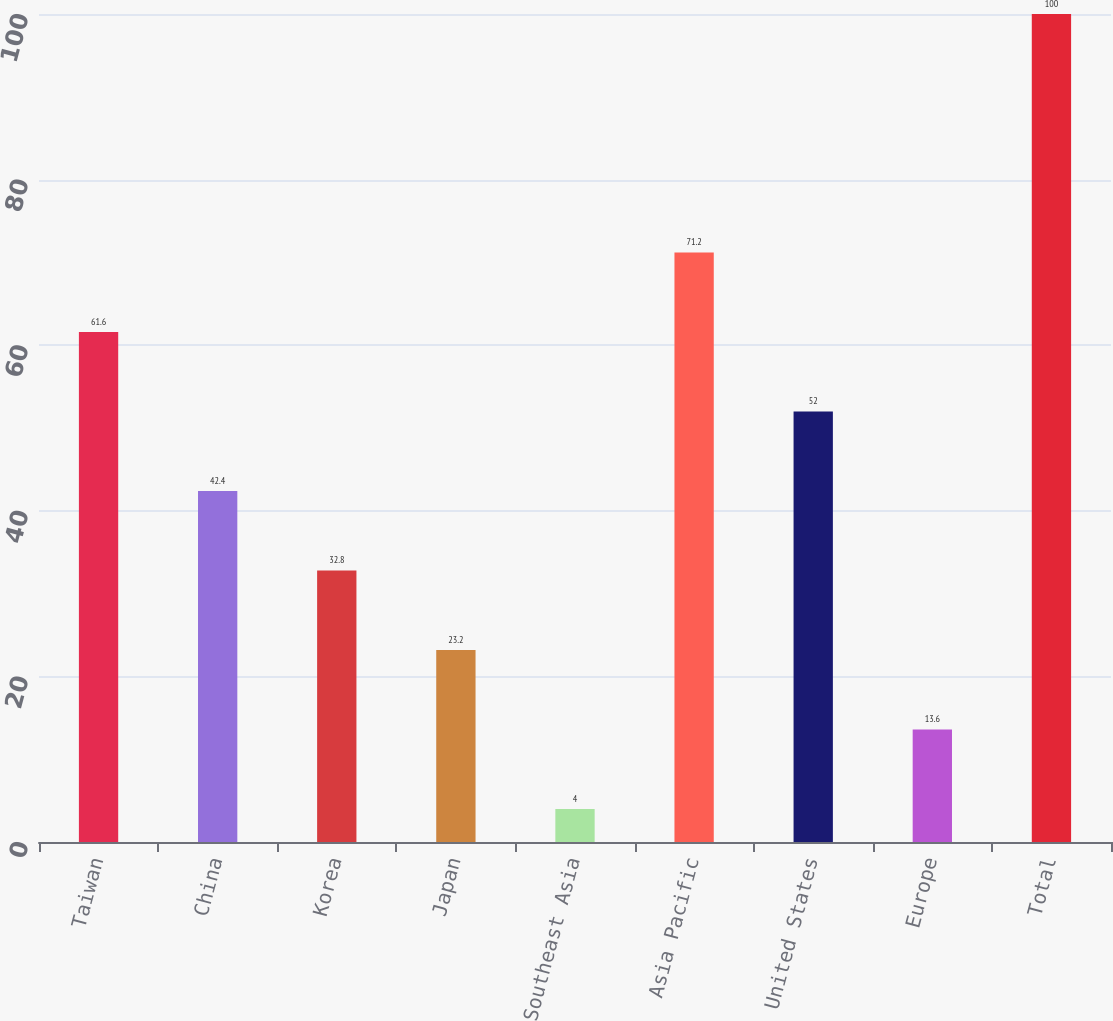Convert chart to OTSL. <chart><loc_0><loc_0><loc_500><loc_500><bar_chart><fcel>Taiwan<fcel>China<fcel>Korea<fcel>Japan<fcel>Southeast Asia<fcel>Asia Pacific<fcel>United States<fcel>Europe<fcel>Total<nl><fcel>61.6<fcel>42.4<fcel>32.8<fcel>23.2<fcel>4<fcel>71.2<fcel>52<fcel>13.6<fcel>100<nl></chart> 